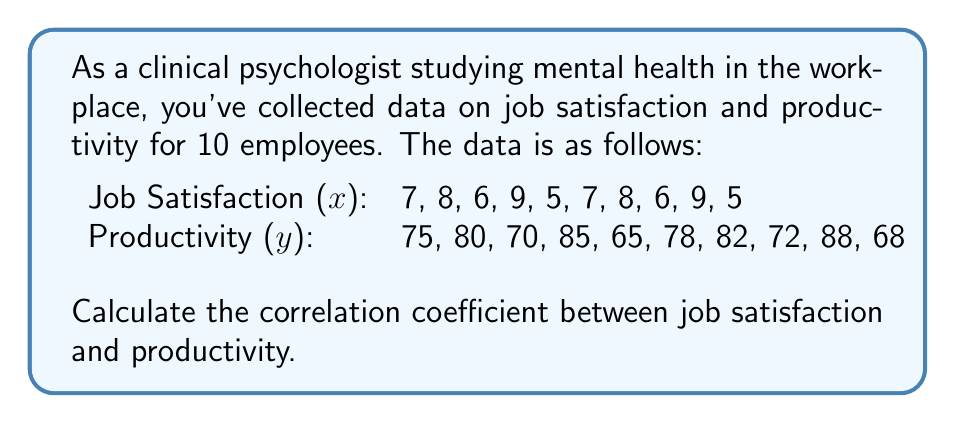Can you solve this math problem? To calculate the correlation coefficient (r), we'll use the formula:

$$ r = \frac{n\sum xy - (\sum x)(\sum y)}{\sqrt{[n\sum x^2 - (\sum x)^2][n\sum y^2 - (\sum y)^2]}} $$

Where:
n = number of pairs of data
x = job satisfaction scores
y = productivity scores

Step 1: Calculate the required sums:
n = 10
$\sum x = 70$
$\sum y = 763$
$\sum xy = 5,431$
$\sum x^2 = 506$
$\sum y^2 = 58,713$

Step 2: Apply the formula:

$$ r = \frac{10(5,431) - (70)(763)}{\sqrt{[10(506) - 70^2][10(58,713) - 763^2]}} $$

Step 3: Simplify:

$$ r = \frac{54,310 - 53,410}{\sqrt{(5,060 - 4,900)(587,130 - 582,169)}} $$

$$ r = \frac{900}{\sqrt{160 * 4,961}} $$

$$ r = \frac{900}{\sqrt{793,760}} $$

$$ r = \frac{900}{891.49} $$

Step 4: Calculate the final result:

$$ r \approx 0.9983 $$

This indicates a very strong positive correlation between job satisfaction and productivity.
Answer: $r \approx 0.9983$ 